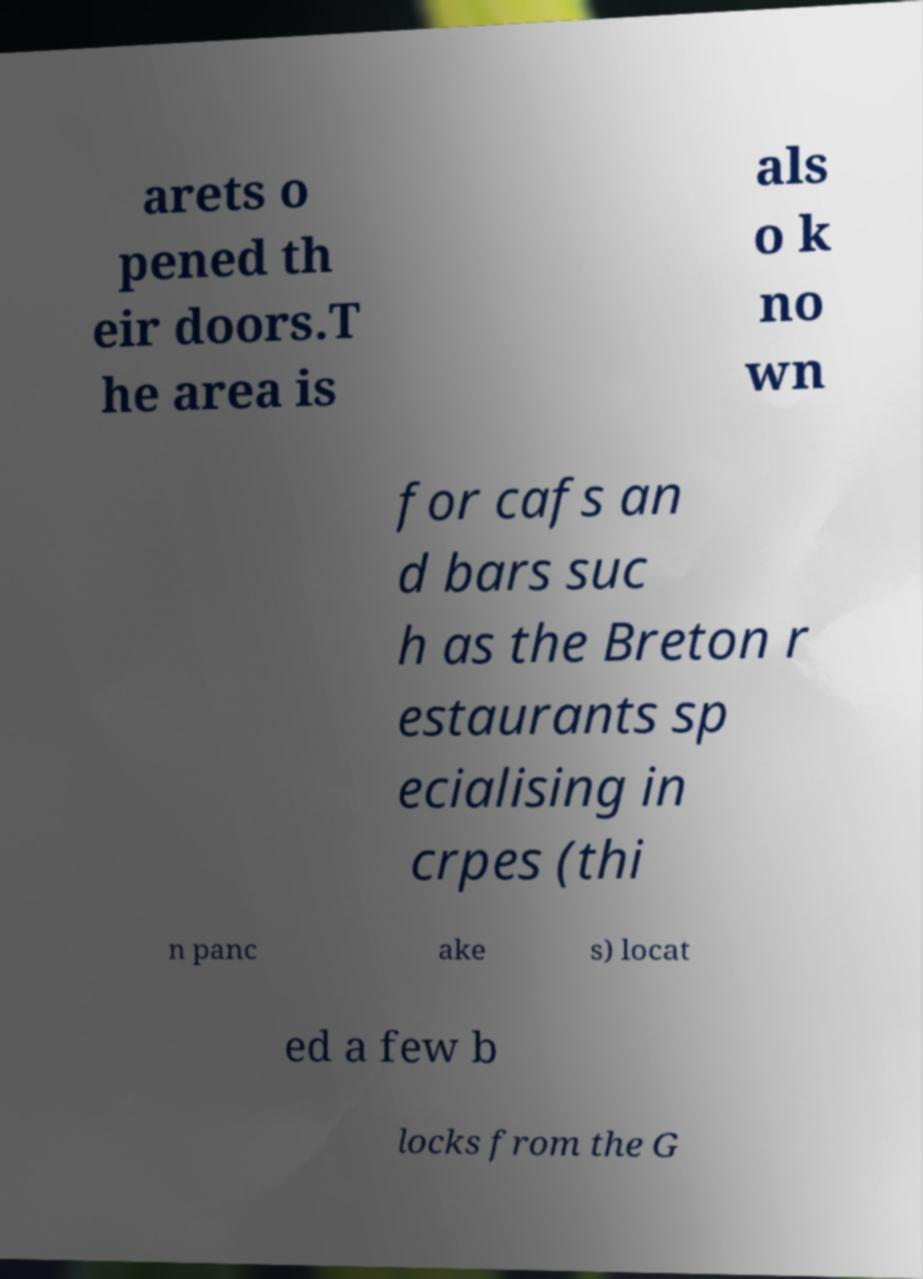Can you read and provide the text displayed in the image?This photo seems to have some interesting text. Can you extract and type it out for me? arets o pened th eir doors.T he area is als o k no wn for cafs an d bars suc h as the Breton r estaurants sp ecialising in crpes (thi n panc ake s) locat ed a few b locks from the G 